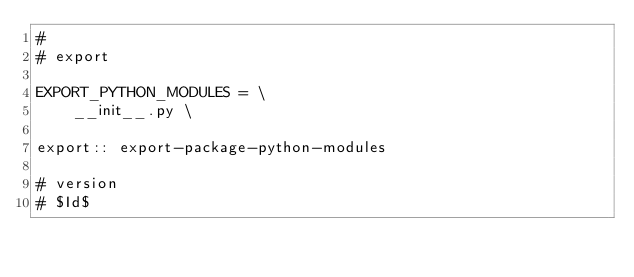Convert code to text. <code><loc_0><loc_0><loc_500><loc_500><_ObjectiveC_>#
# export

EXPORT_PYTHON_MODULES = \
    __init__.py \

export:: export-package-python-modules

# version
# $Id$
</code> 